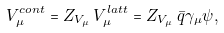<formula> <loc_0><loc_0><loc_500><loc_500>V _ { \mu } ^ { c o n t } = Z _ { V _ { \mu } } \, V _ { \mu } ^ { l a t t } = Z _ { V _ { \mu } } \, \bar { q } \gamma _ { \mu } \psi ,</formula> 